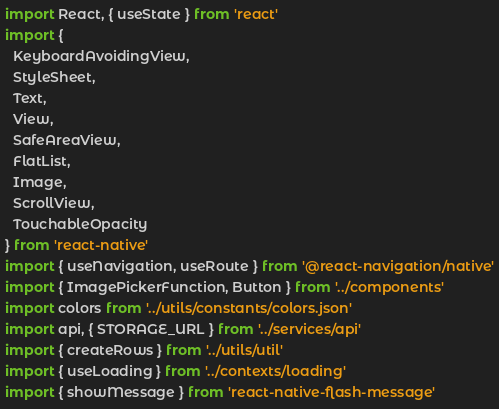<code> <loc_0><loc_0><loc_500><loc_500><_JavaScript_>import React, { useState } from 'react'
import {
  KeyboardAvoidingView,
  StyleSheet,
  Text,
  View,
  SafeAreaView,
  FlatList,
  Image,
  ScrollView,
  TouchableOpacity
} from 'react-native'
import { useNavigation, useRoute } from '@react-navigation/native'
import { ImagePickerFunction, Button } from '../components'
import colors from '../utils/constants/colors.json'
import api, { STORAGE_URL } from '../services/api'
import { createRows } from '../utils/util'
import { useLoading } from '../contexts/loading'
import { showMessage } from 'react-native-flash-message'
</code> 